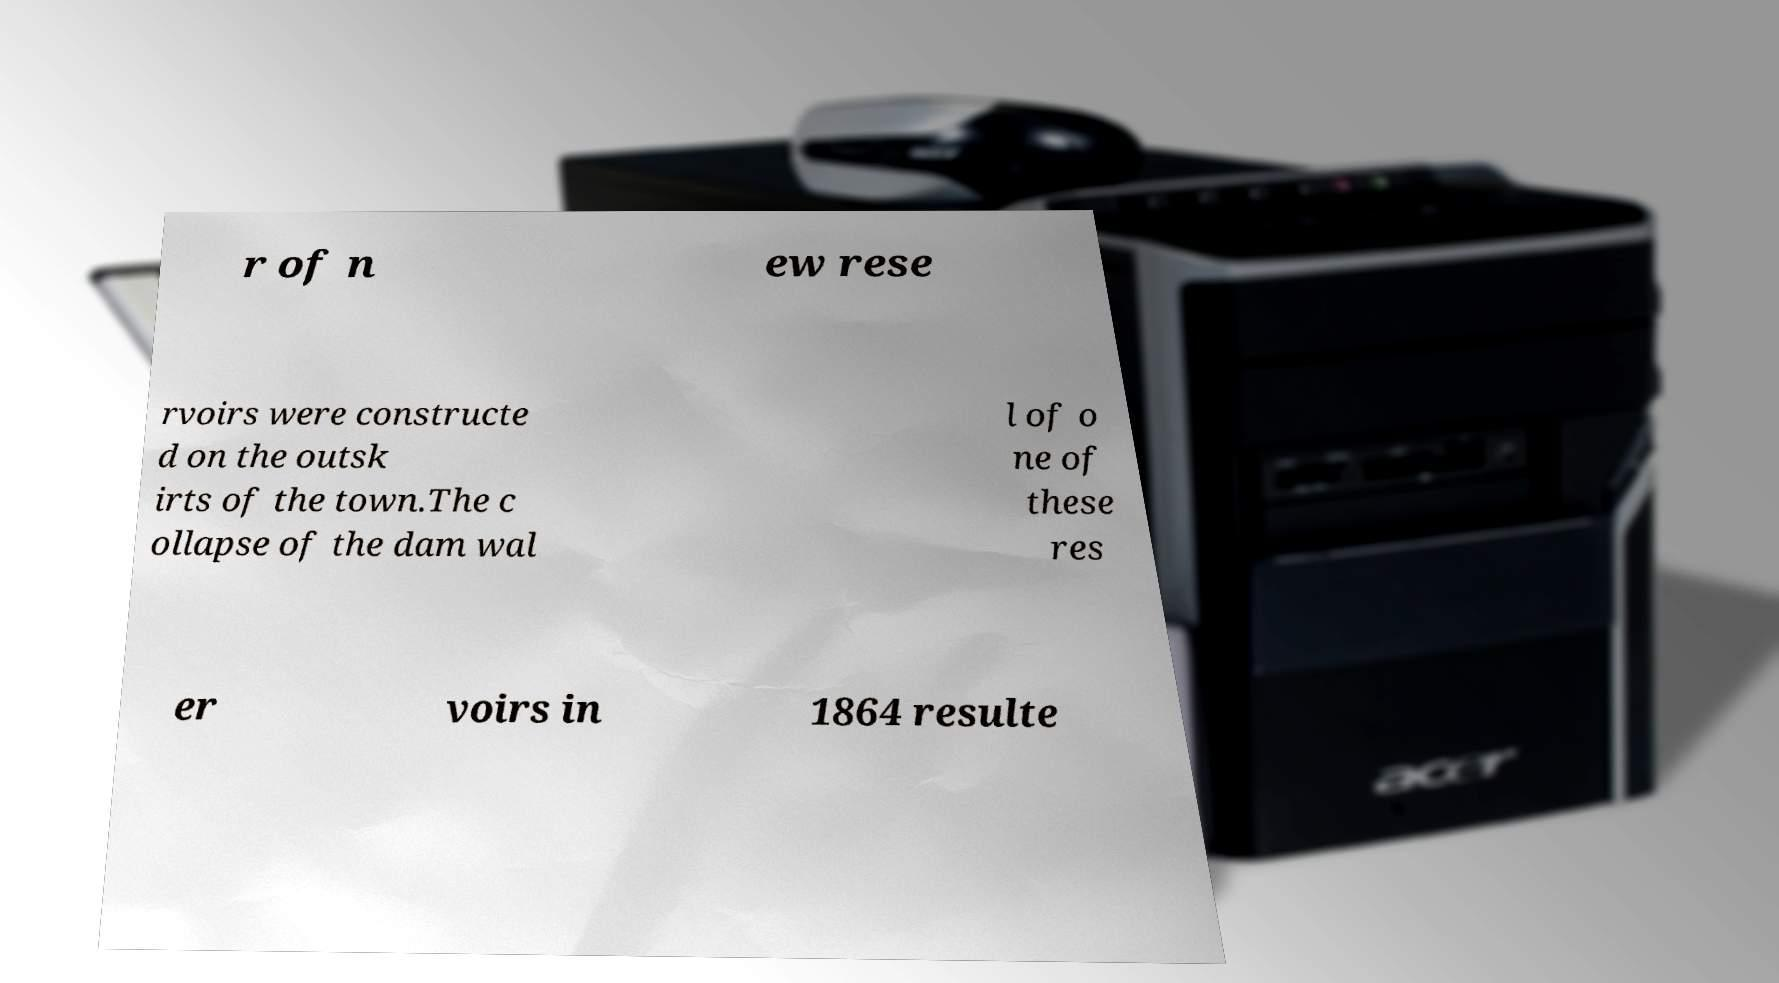Can you accurately transcribe the text from the provided image for me? r of n ew rese rvoirs were constructe d on the outsk irts of the town.The c ollapse of the dam wal l of o ne of these res er voirs in 1864 resulte 